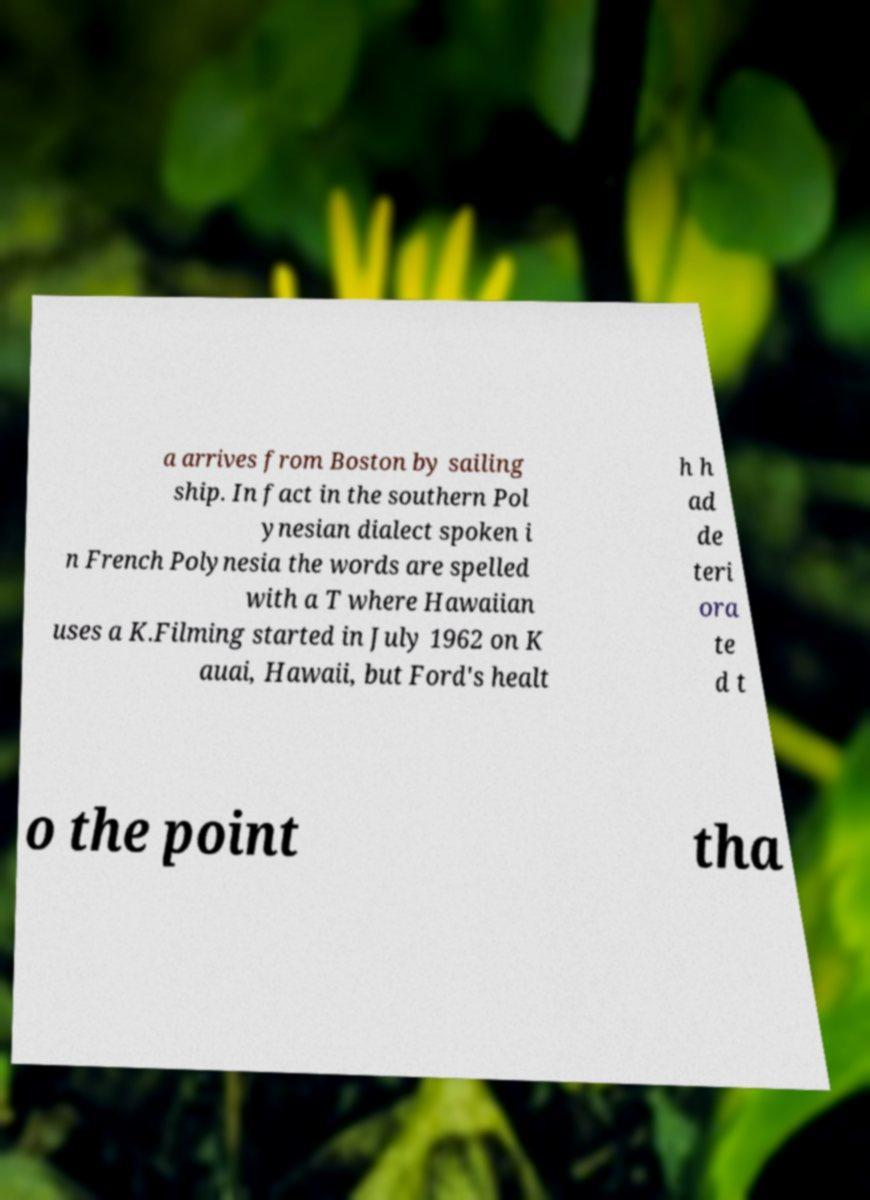Please read and relay the text visible in this image. What does it say? a arrives from Boston by sailing ship. In fact in the southern Pol ynesian dialect spoken i n French Polynesia the words are spelled with a T where Hawaiian uses a K.Filming started in July 1962 on K auai, Hawaii, but Ford's healt h h ad de teri ora te d t o the point tha 